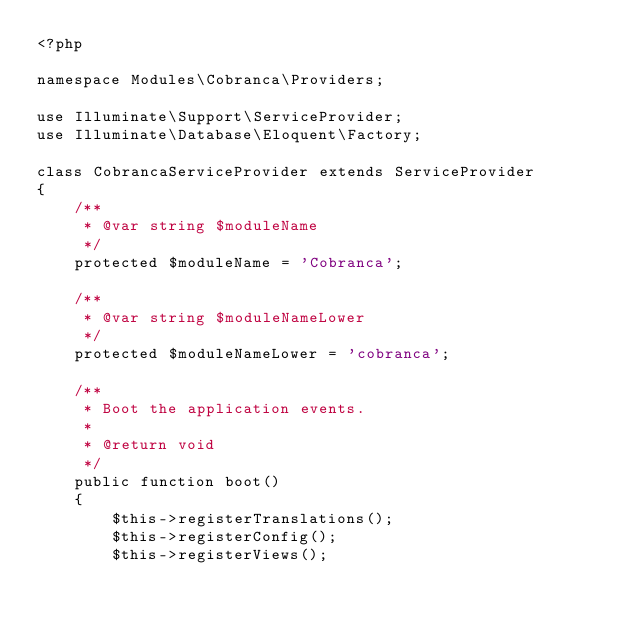<code> <loc_0><loc_0><loc_500><loc_500><_PHP_><?php

namespace Modules\Cobranca\Providers;

use Illuminate\Support\ServiceProvider;
use Illuminate\Database\Eloquent\Factory;

class CobrancaServiceProvider extends ServiceProvider
{
    /**
     * @var string $moduleName
     */
    protected $moduleName = 'Cobranca';

    /**
     * @var string $moduleNameLower
     */
    protected $moduleNameLower = 'cobranca';

    /**
     * Boot the application events.
     *
     * @return void
     */
    public function boot()
    {
        $this->registerTranslations();
        $this->registerConfig();
        $this->registerViews();</code> 